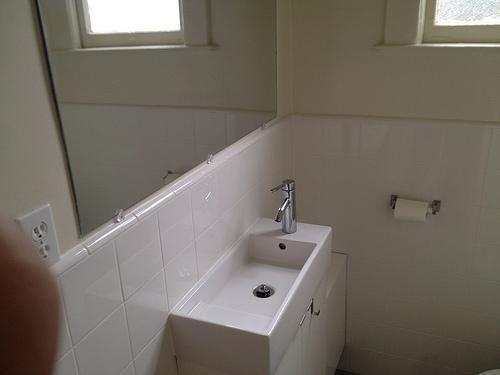How many individual pictures of a window can be seen in this photograph?
Give a very brief answer. 2. How many sockets does the electrical outlet have?
Give a very brief answer. 2. How many electrical outlets are pictured?
Give a very brief answer. 1. 